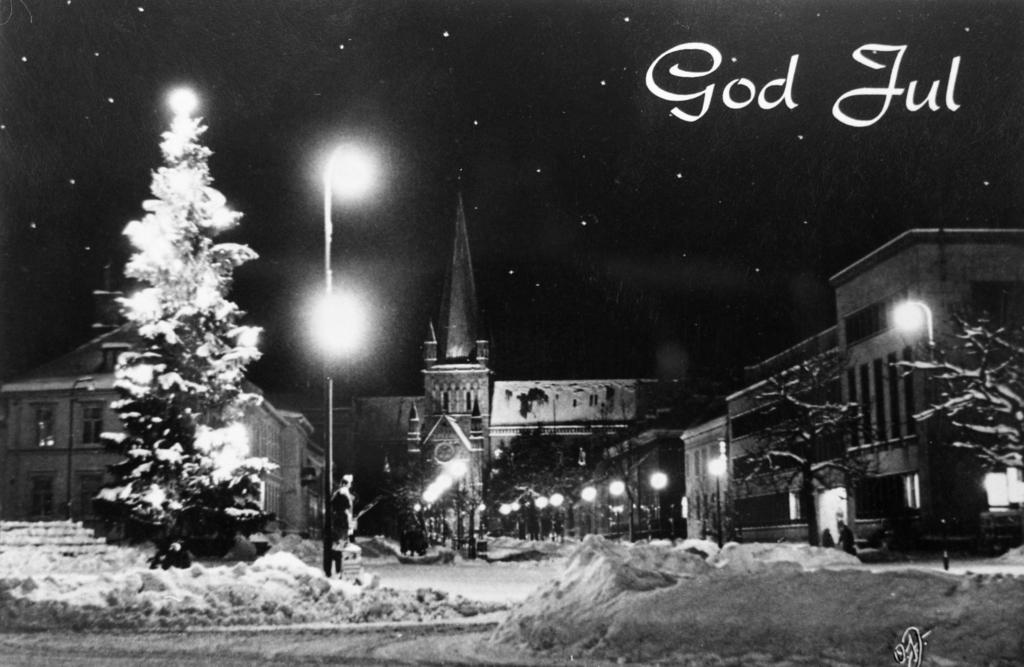What type of structures can be seen in the image? There are buildings in the image. What is the condition of the buildings and trees in the image? The buildings and trees are covered with snow. Can you describe any additional elements in the image? There is text or writing in the right top corner of the image. What type of instrument is being played by the yoke in the image? There is no yoke or instrument present in the image. 